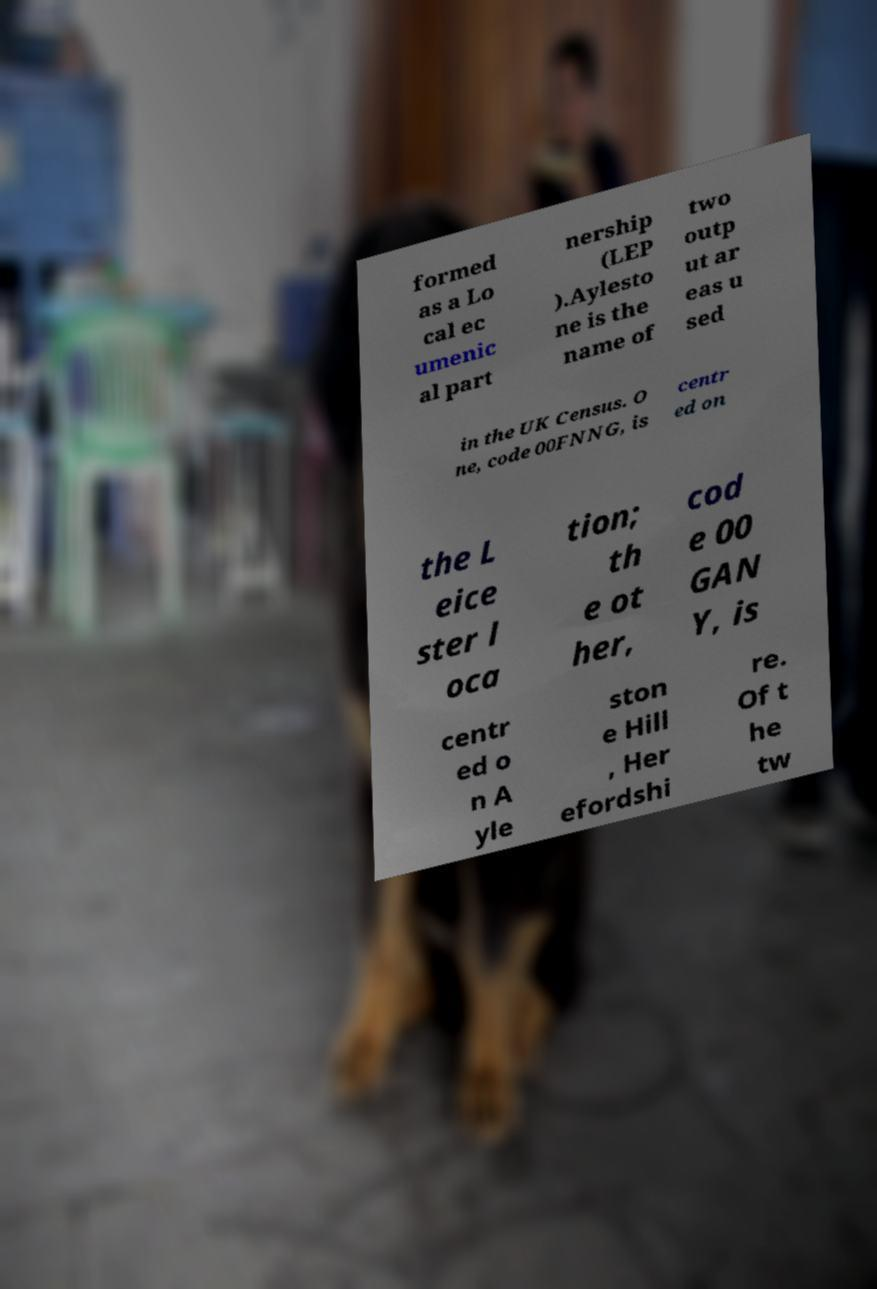Please identify and transcribe the text found in this image. formed as a Lo cal ec umenic al part nership (LEP ).Aylesto ne is the name of two outp ut ar eas u sed in the UK Census. O ne, code 00FNNG, is centr ed on the L eice ster l oca tion; th e ot her, cod e 00 GAN Y, is centr ed o n A yle ston e Hill , Her efordshi re. Of t he tw 